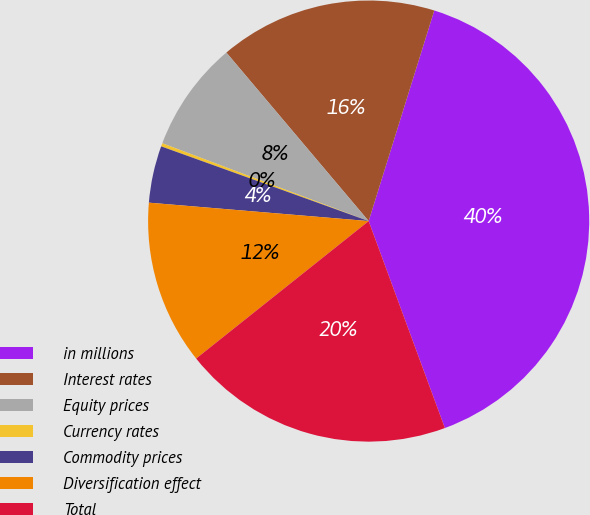Convert chart to OTSL. <chart><loc_0><loc_0><loc_500><loc_500><pie_chart><fcel>in millions<fcel>Interest rates<fcel>Equity prices<fcel>Currency rates<fcel>Commodity prices<fcel>Diversification effect<fcel>Total<nl><fcel>39.58%<fcel>15.97%<fcel>8.1%<fcel>0.24%<fcel>4.17%<fcel>12.04%<fcel>19.91%<nl></chart> 